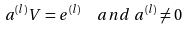Convert formula to latex. <formula><loc_0><loc_0><loc_500><loc_500>a ^ { ( l ) } V & = e ^ { ( l ) } \quad a n d \ a ^ { ( l ) } \neq 0</formula> 